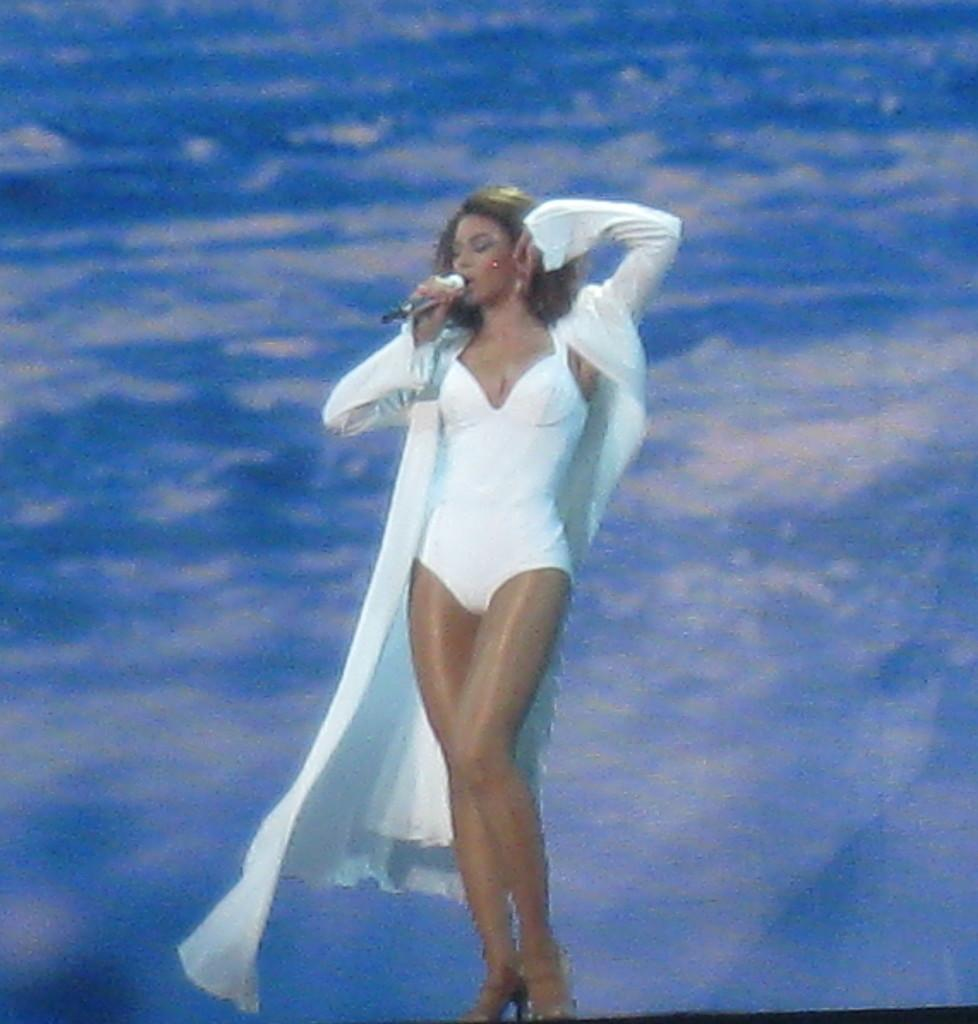Who is the main subject in the image? There is a woman in the image. What is the woman wearing? The woman is wearing a white dress. What is the woman holding in the image? The woman is holding a microphone. What is the woman doing in the image? The woman is singing. What can be seen in the background of the image? There is a blue and white background in the image. What type of meat can be seen on the woman's plate in the image? There is no plate or meat present in the image; the woman is holding a microphone and singing. 